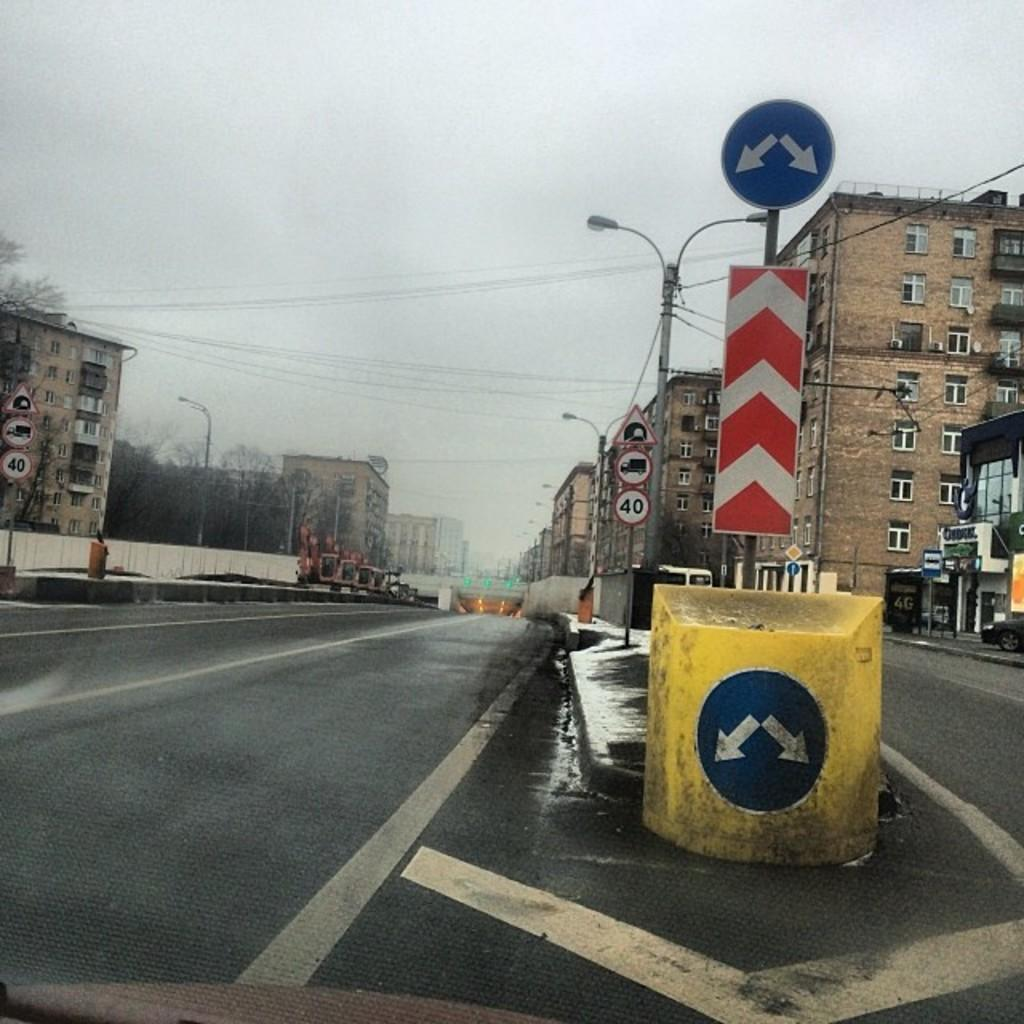What is the main feature of the image? There is a road in the image. What other objects can be seen along the road? There are boards, poles, lights, buildings, trees, a vehicle, and wires in the image. What type of structure is present above the road? There is a flyover in the image. What can be seen in the background of the image? The sky is visible in the background of the image. What is the weight of the operation being performed on the way in the image? There is no operation or weight mentioned in the image; it features a road with various objects and structures. 